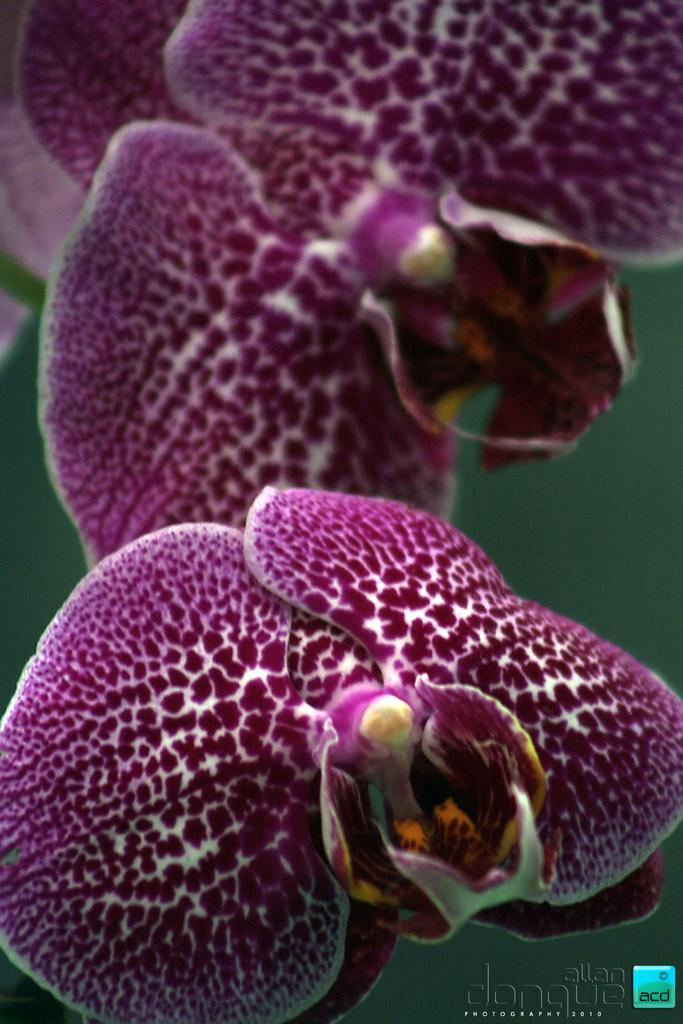What type of flowers are present in the image? There are purple flowers in the image. Can you describe any additional features of the flowers? The purple flowers have a white design over them. What time is displayed on the calculator in the image? There is no calculator present in the image, so we cannot determine the time displayed on it. 